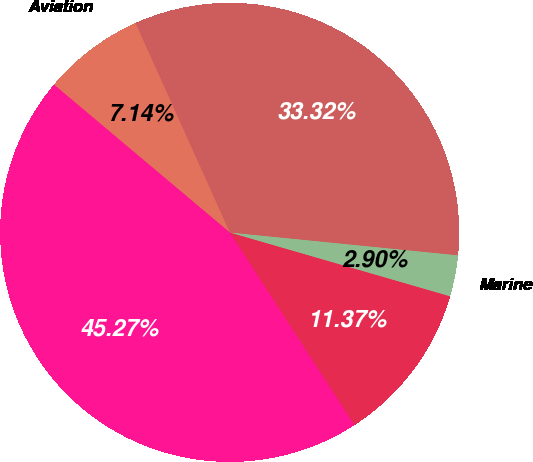Convert chart to OTSL. <chart><loc_0><loc_0><loc_500><loc_500><pie_chart><fcel>Outdoor/Fitness<fcel>Marine<fcel>Automotive/Mobile<fcel>Aviation<fcel>Total<nl><fcel>11.37%<fcel>2.9%<fcel>33.32%<fcel>7.14%<fcel>45.27%<nl></chart> 